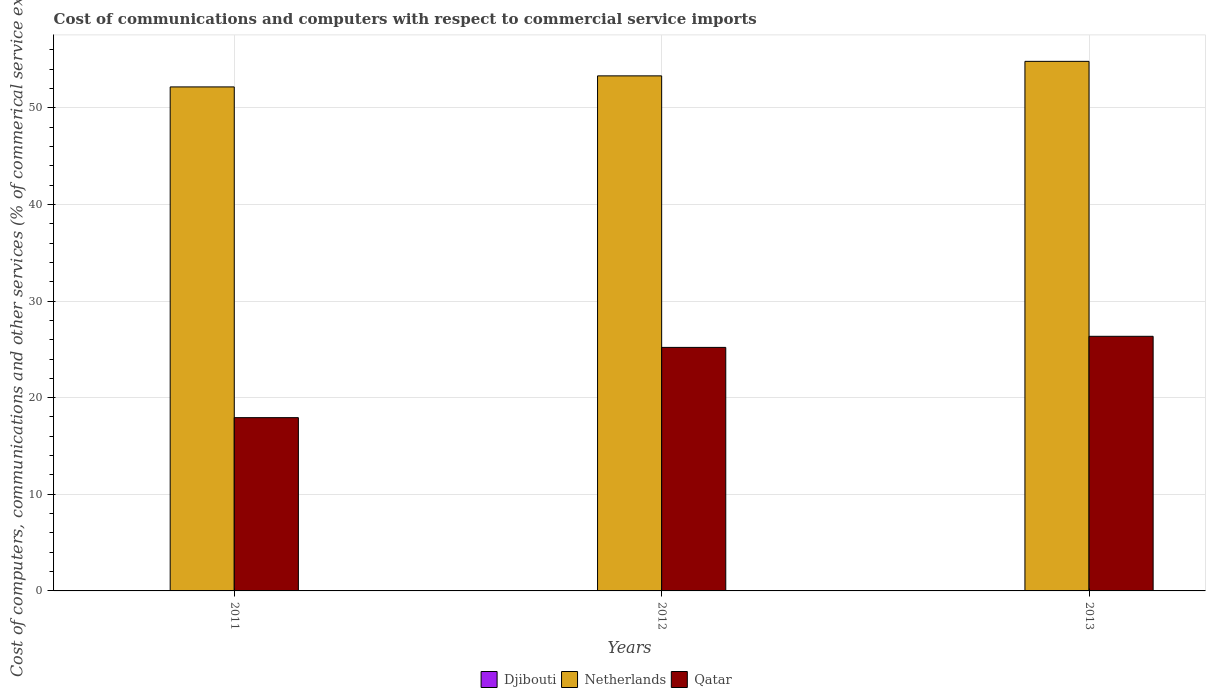How many different coloured bars are there?
Give a very brief answer. 3. Are the number of bars per tick equal to the number of legend labels?
Provide a succinct answer. No. Are the number of bars on each tick of the X-axis equal?
Give a very brief answer. No. What is the label of the 3rd group of bars from the left?
Your answer should be very brief. 2013. In how many cases, is the number of bars for a given year not equal to the number of legend labels?
Your answer should be very brief. 2. What is the cost of communications and computers in Qatar in 2012?
Your answer should be compact. 25.2. Across all years, what is the maximum cost of communications and computers in Netherlands?
Offer a very short reply. 54.81. Across all years, what is the minimum cost of communications and computers in Qatar?
Your response must be concise. 17.93. In which year was the cost of communications and computers in Qatar maximum?
Make the answer very short. 2013. What is the total cost of communications and computers in Qatar in the graph?
Ensure brevity in your answer.  69.49. What is the difference between the cost of communications and computers in Qatar in 2011 and that in 2012?
Ensure brevity in your answer.  -7.27. What is the difference between the cost of communications and computers in Qatar in 2012 and the cost of communications and computers in Djibouti in 2013?
Provide a short and direct response. 25.2. What is the average cost of communications and computers in Netherlands per year?
Give a very brief answer. 53.42. In the year 2013, what is the difference between the cost of communications and computers in Qatar and cost of communications and computers in Netherlands?
Ensure brevity in your answer.  -28.46. In how many years, is the cost of communications and computers in Qatar greater than 52 %?
Your answer should be very brief. 0. What is the ratio of the cost of communications and computers in Netherlands in 2011 to that in 2013?
Give a very brief answer. 0.95. Is the difference between the cost of communications and computers in Qatar in 2011 and 2013 greater than the difference between the cost of communications and computers in Netherlands in 2011 and 2013?
Offer a very short reply. No. What is the difference between the highest and the second highest cost of communications and computers in Qatar?
Your response must be concise. 1.15. What is the difference between the highest and the lowest cost of communications and computers in Netherlands?
Ensure brevity in your answer.  2.65. Is the sum of the cost of communications and computers in Qatar in 2011 and 2013 greater than the maximum cost of communications and computers in Djibouti across all years?
Keep it short and to the point. Yes. What is the difference between two consecutive major ticks on the Y-axis?
Ensure brevity in your answer.  10. Are the values on the major ticks of Y-axis written in scientific E-notation?
Give a very brief answer. No. Where does the legend appear in the graph?
Make the answer very short. Bottom center. How are the legend labels stacked?
Offer a terse response. Horizontal. What is the title of the graph?
Your answer should be compact. Cost of communications and computers with respect to commercial service imports. What is the label or title of the Y-axis?
Provide a short and direct response. Cost of computers, communications and other services (% of commerical service exports). What is the Cost of computers, communications and other services (% of commerical service exports) in Djibouti in 2011?
Your response must be concise. 0. What is the Cost of computers, communications and other services (% of commerical service exports) of Netherlands in 2011?
Offer a very short reply. 52.16. What is the Cost of computers, communications and other services (% of commerical service exports) of Qatar in 2011?
Provide a short and direct response. 17.93. What is the Cost of computers, communications and other services (% of commerical service exports) in Djibouti in 2012?
Offer a terse response. 1.70530256582424e-13. What is the Cost of computers, communications and other services (% of commerical service exports) in Netherlands in 2012?
Give a very brief answer. 53.3. What is the Cost of computers, communications and other services (% of commerical service exports) of Qatar in 2012?
Offer a terse response. 25.2. What is the Cost of computers, communications and other services (% of commerical service exports) of Netherlands in 2013?
Your answer should be compact. 54.81. What is the Cost of computers, communications and other services (% of commerical service exports) of Qatar in 2013?
Provide a succinct answer. 26.35. Across all years, what is the maximum Cost of computers, communications and other services (% of commerical service exports) in Djibouti?
Make the answer very short. 1.70530256582424e-13. Across all years, what is the maximum Cost of computers, communications and other services (% of commerical service exports) in Netherlands?
Make the answer very short. 54.81. Across all years, what is the maximum Cost of computers, communications and other services (% of commerical service exports) of Qatar?
Make the answer very short. 26.35. Across all years, what is the minimum Cost of computers, communications and other services (% of commerical service exports) of Netherlands?
Keep it short and to the point. 52.16. Across all years, what is the minimum Cost of computers, communications and other services (% of commerical service exports) of Qatar?
Provide a succinct answer. 17.93. What is the total Cost of computers, communications and other services (% of commerical service exports) of Netherlands in the graph?
Offer a terse response. 160.27. What is the total Cost of computers, communications and other services (% of commerical service exports) in Qatar in the graph?
Ensure brevity in your answer.  69.49. What is the difference between the Cost of computers, communications and other services (% of commerical service exports) of Netherlands in 2011 and that in 2012?
Make the answer very short. -1.14. What is the difference between the Cost of computers, communications and other services (% of commerical service exports) in Qatar in 2011 and that in 2012?
Offer a very short reply. -7.27. What is the difference between the Cost of computers, communications and other services (% of commerical service exports) of Netherlands in 2011 and that in 2013?
Offer a terse response. -2.65. What is the difference between the Cost of computers, communications and other services (% of commerical service exports) of Qatar in 2011 and that in 2013?
Keep it short and to the point. -8.42. What is the difference between the Cost of computers, communications and other services (% of commerical service exports) in Netherlands in 2012 and that in 2013?
Your response must be concise. -1.5. What is the difference between the Cost of computers, communications and other services (% of commerical service exports) of Qatar in 2012 and that in 2013?
Ensure brevity in your answer.  -1.15. What is the difference between the Cost of computers, communications and other services (% of commerical service exports) of Netherlands in 2011 and the Cost of computers, communications and other services (% of commerical service exports) of Qatar in 2012?
Provide a short and direct response. 26.96. What is the difference between the Cost of computers, communications and other services (% of commerical service exports) in Netherlands in 2011 and the Cost of computers, communications and other services (% of commerical service exports) in Qatar in 2013?
Provide a succinct answer. 25.81. What is the difference between the Cost of computers, communications and other services (% of commerical service exports) of Djibouti in 2012 and the Cost of computers, communications and other services (% of commerical service exports) of Netherlands in 2013?
Your answer should be compact. -54.81. What is the difference between the Cost of computers, communications and other services (% of commerical service exports) in Djibouti in 2012 and the Cost of computers, communications and other services (% of commerical service exports) in Qatar in 2013?
Give a very brief answer. -26.35. What is the difference between the Cost of computers, communications and other services (% of commerical service exports) of Netherlands in 2012 and the Cost of computers, communications and other services (% of commerical service exports) of Qatar in 2013?
Your answer should be compact. 26.95. What is the average Cost of computers, communications and other services (% of commerical service exports) in Netherlands per year?
Provide a short and direct response. 53.42. What is the average Cost of computers, communications and other services (% of commerical service exports) in Qatar per year?
Provide a short and direct response. 23.16. In the year 2011, what is the difference between the Cost of computers, communications and other services (% of commerical service exports) in Netherlands and Cost of computers, communications and other services (% of commerical service exports) in Qatar?
Keep it short and to the point. 34.23. In the year 2012, what is the difference between the Cost of computers, communications and other services (% of commerical service exports) in Djibouti and Cost of computers, communications and other services (% of commerical service exports) in Netherlands?
Your response must be concise. -53.3. In the year 2012, what is the difference between the Cost of computers, communications and other services (% of commerical service exports) in Djibouti and Cost of computers, communications and other services (% of commerical service exports) in Qatar?
Your answer should be very brief. -25.2. In the year 2012, what is the difference between the Cost of computers, communications and other services (% of commerical service exports) in Netherlands and Cost of computers, communications and other services (% of commerical service exports) in Qatar?
Ensure brevity in your answer.  28.1. In the year 2013, what is the difference between the Cost of computers, communications and other services (% of commerical service exports) in Netherlands and Cost of computers, communications and other services (% of commerical service exports) in Qatar?
Make the answer very short. 28.46. What is the ratio of the Cost of computers, communications and other services (% of commerical service exports) in Netherlands in 2011 to that in 2012?
Provide a short and direct response. 0.98. What is the ratio of the Cost of computers, communications and other services (% of commerical service exports) in Qatar in 2011 to that in 2012?
Give a very brief answer. 0.71. What is the ratio of the Cost of computers, communications and other services (% of commerical service exports) of Netherlands in 2011 to that in 2013?
Offer a terse response. 0.95. What is the ratio of the Cost of computers, communications and other services (% of commerical service exports) of Qatar in 2011 to that in 2013?
Give a very brief answer. 0.68. What is the ratio of the Cost of computers, communications and other services (% of commerical service exports) of Netherlands in 2012 to that in 2013?
Your answer should be compact. 0.97. What is the ratio of the Cost of computers, communications and other services (% of commerical service exports) in Qatar in 2012 to that in 2013?
Your response must be concise. 0.96. What is the difference between the highest and the second highest Cost of computers, communications and other services (% of commerical service exports) in Netherlands?
Ensure brevity in your answer.  1.5. What is the difference between the highest and the second highest Cost of computers, communications and other services (% of commerical service exports) in Qatar?
Make the answer very short. 1.15. What is the difference between the highest and the lowest Cost of computers, communications and other services (% of commerical service exports) in Djibouti?
Offer a very short reply. 0. What is the difference between the highest and the lowest Cost of computers, communications and other services (% of commerical service exports) in Netherlands?
Keep it short and to the point. 2.65. What is the difference between the highest and the lowest Cost of computers, communications and other services (% of commerical service exports) in Qatar?
Offer a terse response. 8.42. 